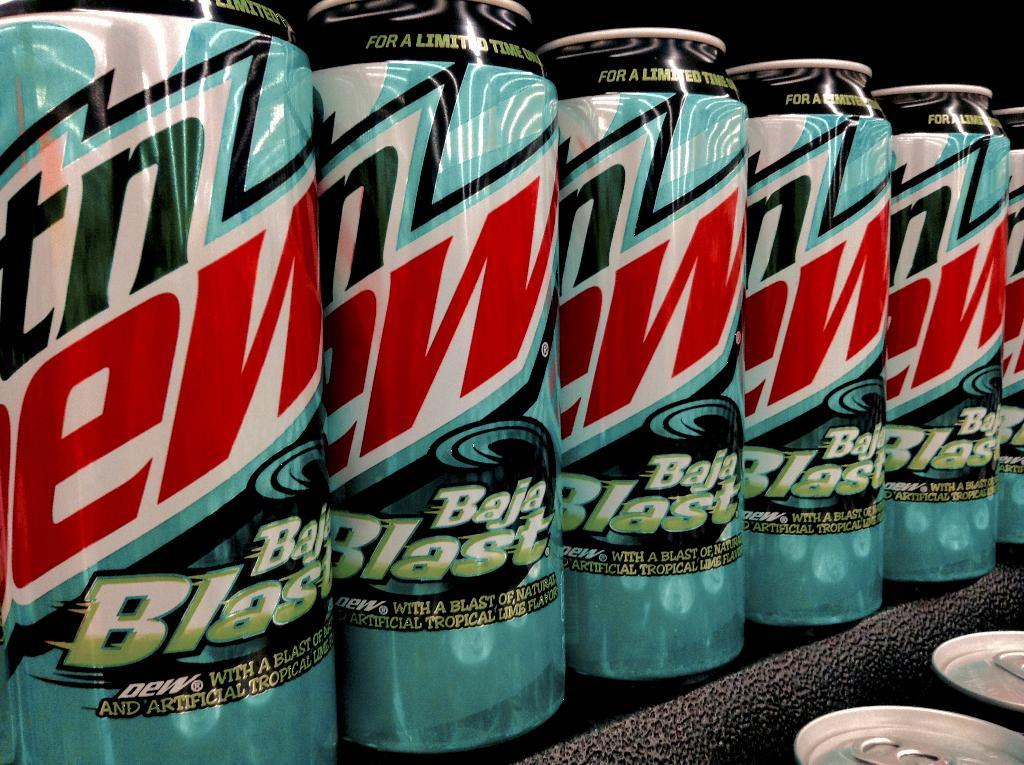<image>
Provide a brief description of the given image. A line up of Baja Blast sodas on a black shelf. 